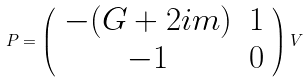Convert formula to latex. <formula><loc_0><loc_0><loc_500><loc_500>P = \left ( \begin{array} { c c } - ( G + 2 i m ) & 1 \\ - 1 & 0 \end{array} \right ) V</formula> 